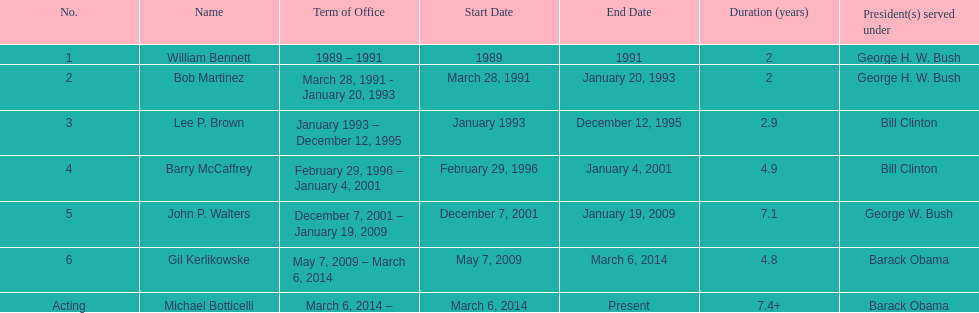Who was the next appointed director after lee p. brown? Barry McCaffrey. 